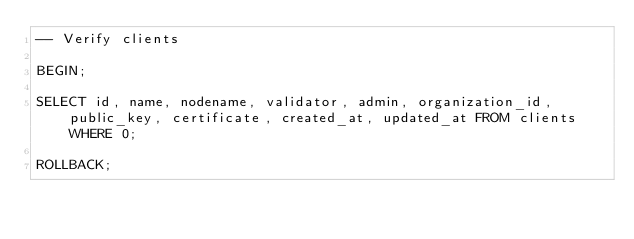Convert code to text. <code><loc_0><loc_0><loc_500><loc_500><_SQL_>-- Verify clients

BEGIN;

SELECT id, name, nodename, validator, admin, organization_id, public_key, certificate, created_at, updated_at FROM clients WHERE 0;

ROLLBACK;
</code> 